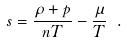<formula> <loc_0><loc_0><loc_500><loc_500>s = \frac { \rho + p } { n T } - \frac { \mu } { T } \ .</formula> 